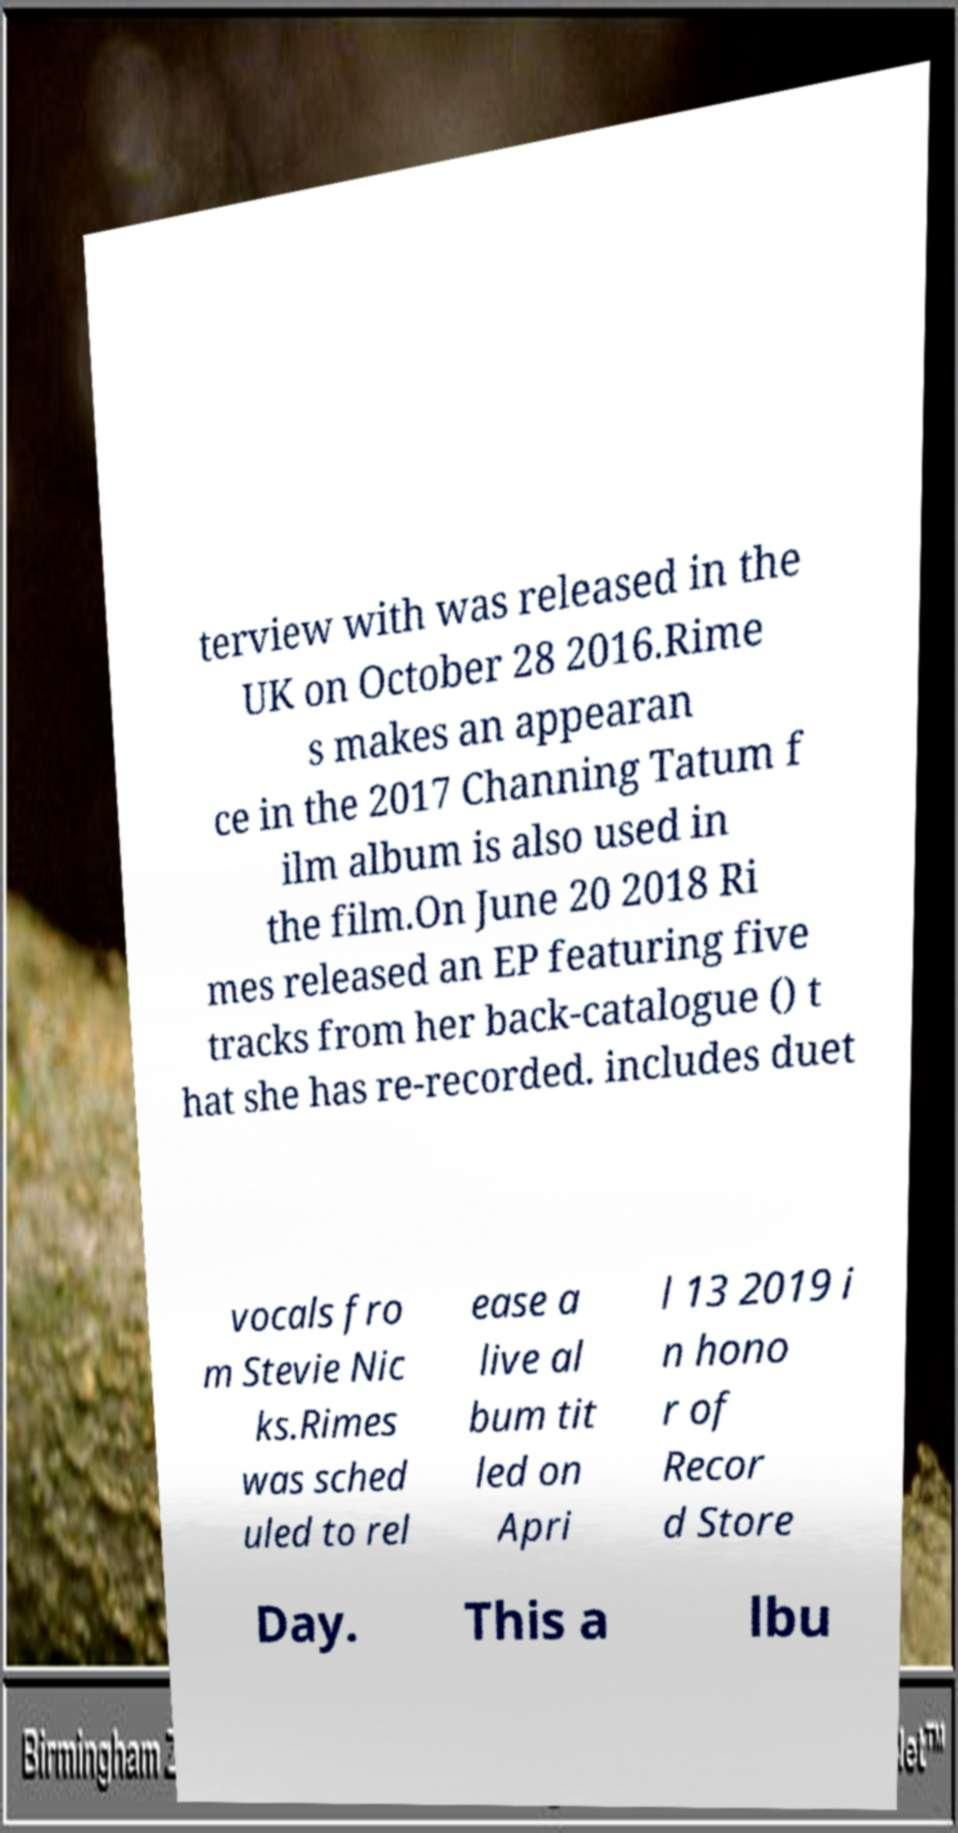Could you extract and type out the text from this image? terview with was released in the UK on October 28 2016.Rime s makes an appearan ce in the 2017 Channing Tatum f ilm album is also used in the film.On June 20 2018 Ri mes released an EP featuring five tracks from her back-catalogue () t hat she has re-recorded. includes duet vocals fro m Stevie Nic ks.Rimes was sched uled to rel ease a live al bum tit led on Apri l 13 2019 i n hono r of Recor d Store Day. This a lbu 